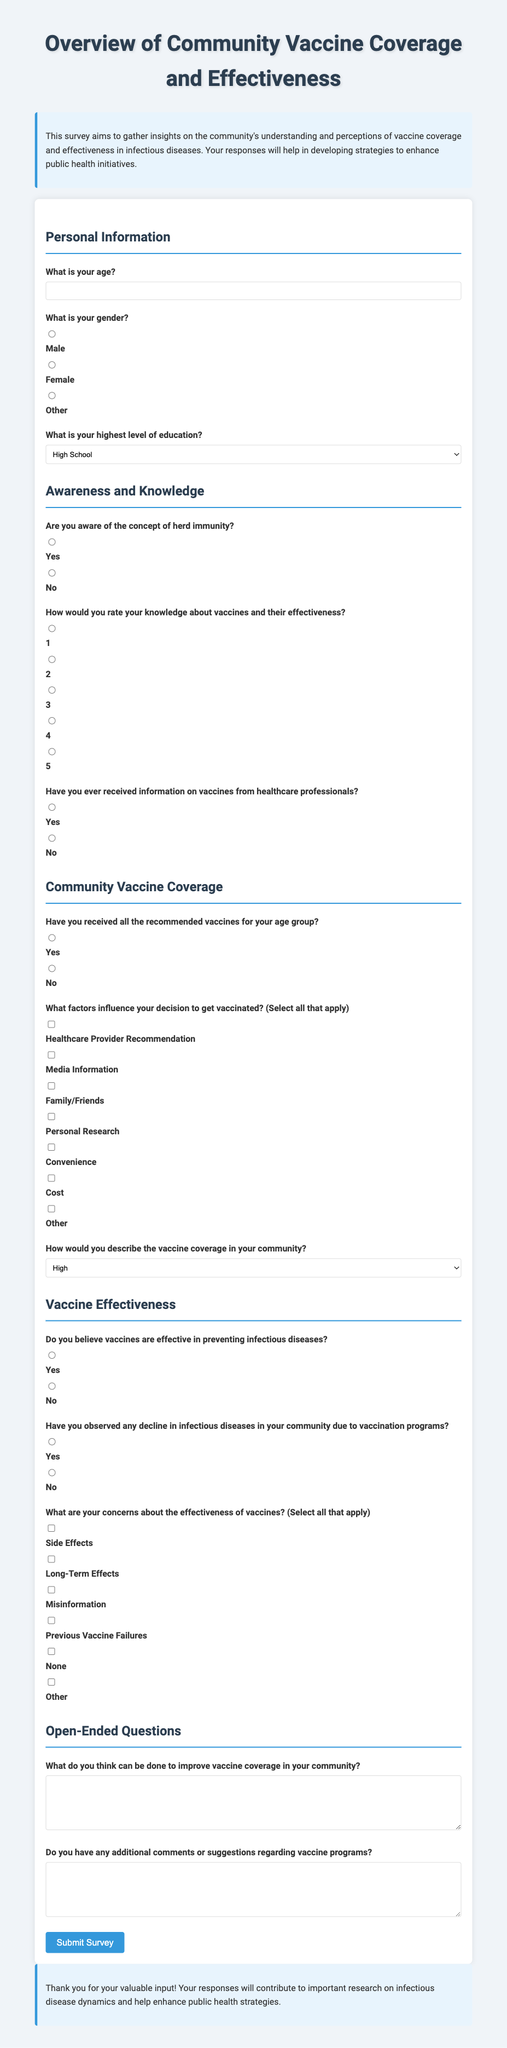What is the title of the survey? The title is explicitly stated at the beginning of the document.
Answer: Overview of Community Vaccine Coverage and Effectiveness What does the survey aim to gather insights on? The purpose of the survey is mentioned in the introduction section of the document.
Answer: Community's understanding and perceptions of vaccine coverage and effectiveness What age group does the survey ask about? The survey includes a question specifically asking for the participant's age in years.
Answer: Age What are the available options for the highest level of education? The options are listed in a dropdown menu in the Personal Information section of the survey.
Answer: High School, Bachelor's Degree, Master's Degree, PhD, Other How many factors can a participant select regarding their decision to get vaccinated? This question is based on the design of the survey which allows multiple selections.
Answer: Multiple factors What is one concern participants might have about the effectiveness of vaccines? The survey lists several concerns regarding vaccine effectiveness, indicating these as selectable options.
Answer: Side Effects How does the survey ask respondents to describe the vaccine coverage in their community? The survey provides a dropdown menu with specific options for respondents to choose from.
Answer: High, Moderate, Low, Not Sure What is the last section of the survey about? The sections of the survey are numbered and labeled, indicating the content of each section.
Answer: Open-Ended Questions How does the survey conclude? The conclusion provides a summary of the survey's purpose and expresses gratitude for participation.
Answer: Thank you for your valuable input! 